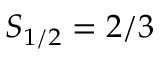Convert formula to latex. <formula><loc_0><loc_0><loc_500><loc_500>S _ { 1 / 2 } = 2 / 3</formula> 